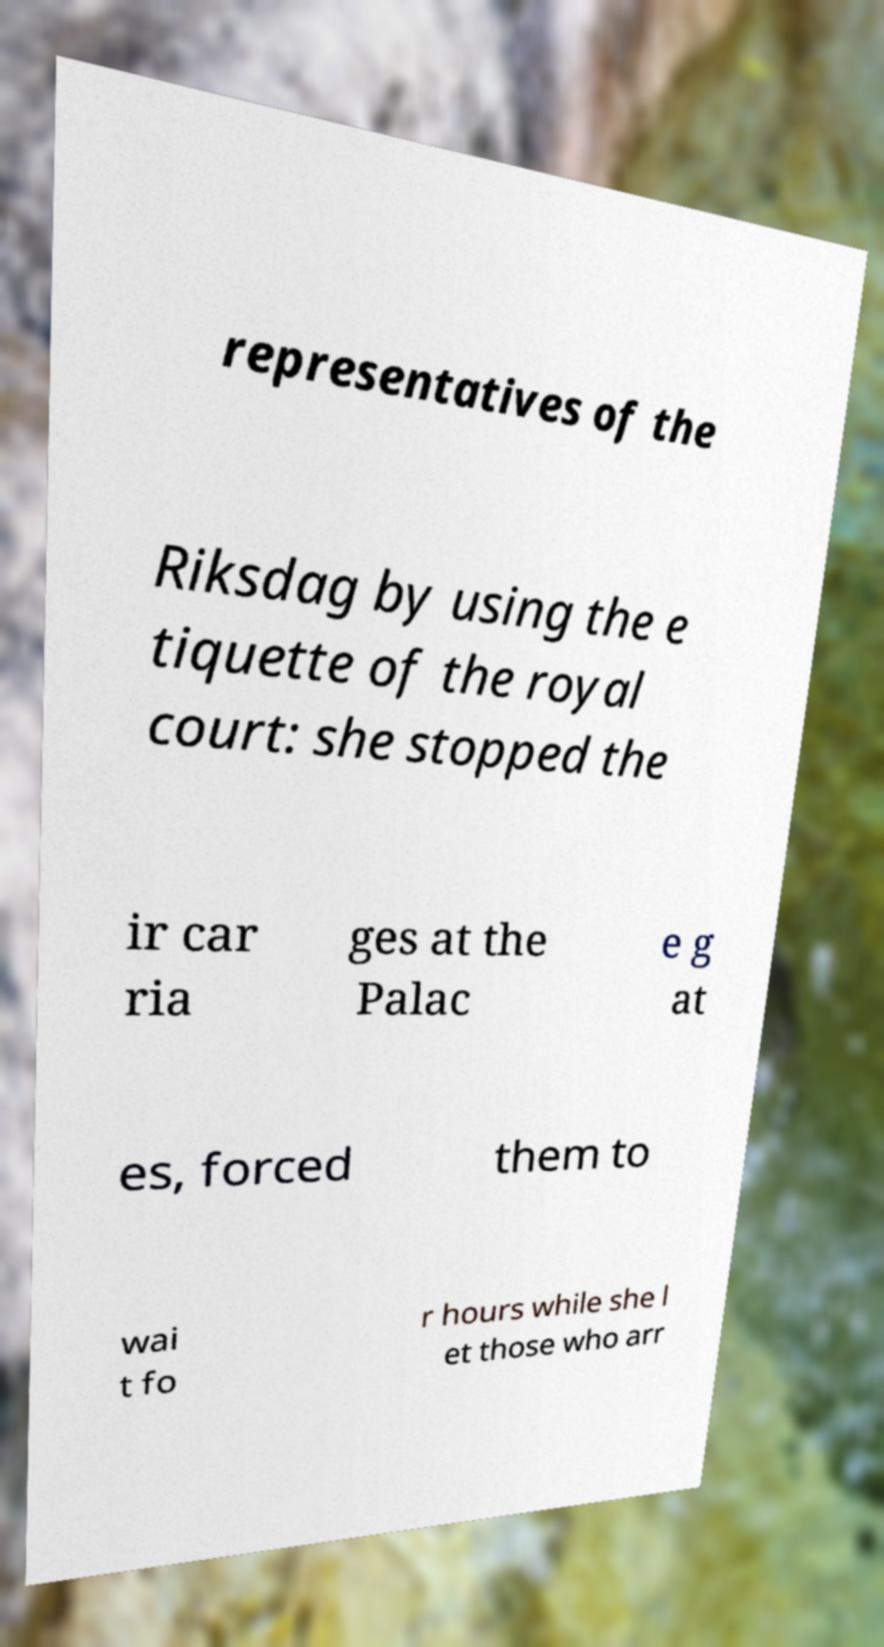Can you accurately transcribe the text from the provided image for me? representatives of the Riksdag by using the e tiquette of the royal court: she stopped the ir car ria ges at the Palac e g at es, forced them to wai t fo r hours while she l et those who arr 